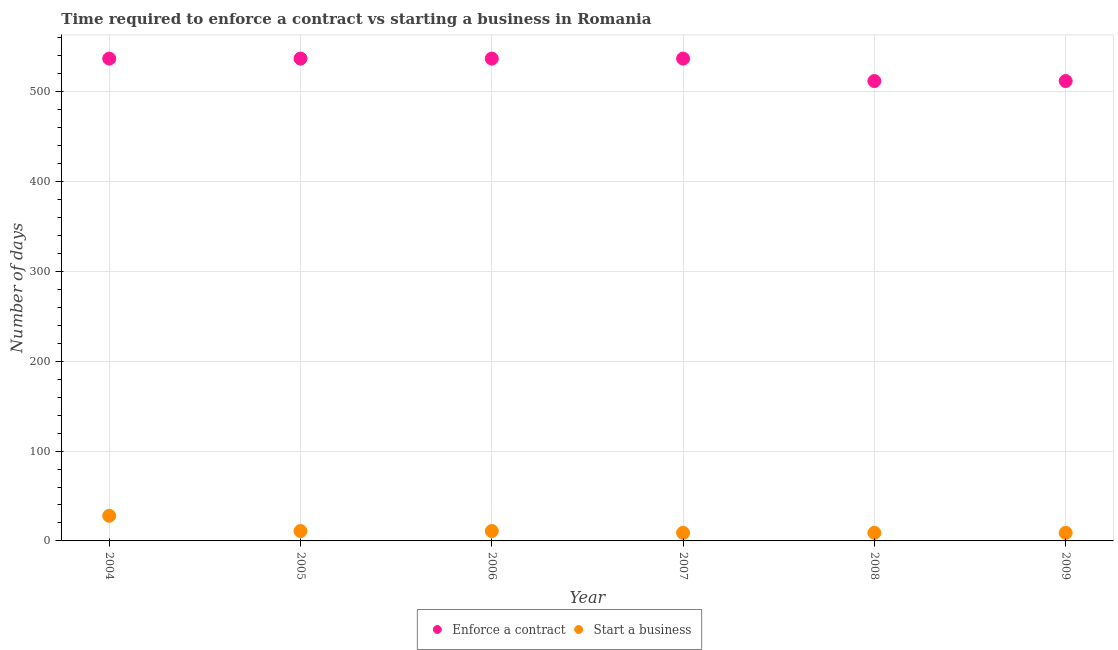What is the number of days to start a business in 2009?
Keep it short and to the point. 9. Across all years, what is the maximum number of days to start a business?
Offer a very short reply. 28. Across all years, what is the minimum number of days to start a business?
Make the answer very short. 9. What is the total number of days to enforece a contract in the graph?
Keep it short and to the point. 3172. What is the difference between the number of days to start a business in 2006 and that in 2007?
Offer a very short reply. 2. What is the difference between the number of days to start a business in 2007 and the number of days to enforece a contract in 2004?
Give a very brief answer. -528. What is the average number of days to enforece a contract per year?
Your response must be concise. 528.67. In the year 2004, what is the difference between the number of days to start a business and number of days to enforece a contract?
Keep it short and to the point. -509. In how many years, is the number of days to start a business greater than 240 days?
Offer a terse response. 0. Is the number of days to enforece a contract in 2007 less than that in 2009?
Ensure brevity in your answer.  No. What is the difference between the highest and the second highest number of days to start a business?
Your response must be concise. 17. What is the difference between the highest and the lowest number of days to enforece a contract?
Ensure brevity in your answer.  25. In how many years, is the number of days to start a business greater than the average number of days to start a business taken over all years?
Provide a succinct answer. 1. Is the sum of the number of days to start a business in 2004 and 2006 greater than the maximum number of days to enforece a contract across all years?
Your response must be concise. No. Does the number of days to start a business monotonically increase over the years?
Keep it short and to the point. No. Is the number of days to start a business strictly greater than the number of days to enforece a contract over the years?
Offer a terse response. No. How many dotlines are there?
Offer a terse response. 2. How many years are there in the graph?
Your answer should be compact. 6. What is the difference between two consecutive major ticks on the Y-axis?
Provide a short and direct response. 100. Are the values on the major ticks of Y-axis written in scientific E-notation?
Make the answer very short. No. Does the graph contain any zero values?
Your answer should be compact. No. Does the graph contain grids?
Your response must be concise. Yes. What is the title of the graph?
Offer a terse response. Time required to enforce a contract vs starting a business in Romania. Does "Non-resident workers" appear as one of the legend labels in the graph?
Offer a very short reply. No. What is the label or title of the X-axis?
Offer a very short reply. Year. What is the label or title of the Y-axis?
Offer a terse response. Number of days. What is the Number of days in Enforce a contract in 2004?
Offer a terse response. 537. What is the Number of days of Enforce a contract in 2005?
Offer a terse response. 537. What is the Number of days of Enforce a contract in 2006?
Provide a short and direct response. 537. What is the Number of days of Start a business in 2006?
Provide a short and direct response. 11. What is the Number of days of Enforce a contract in 2007?
Keep it short and to the point. 537. What is the Number of days of Start a business in 2007?
Make the answer very short. 9. What is the Number of days of Enforce a contract in 2008?
Your response must be concise. 512. What is the Number of days in Enforce a contract in 2009?
Offer a very short reply. 512. What is the Number of days in Start a business in 2009?
Provide a short and direct response. 9. Across all years, what is the maximum Number of days in Enforce a contract?
Provide a short and direct response. 537. Across all years, what is the minimum Number of days in Enforce a contract?
Ensure brevity in your answer.  512. What is the total Number of days of Enforce a contract in the graph?
Your answer should be very brief. 3172. What is the difference between the Number of days of Start a business in 2004 and that in 2005?
Provide a succinct answer. 17. What is the difference between the Number of days in Enforce a contract in 2004 and that in 2006?
Offer a very short reply. 0. What is the difference between the Number of days of Start a business in 2004 and that in 2006?
Keep it short and to the point. 17. What is the difference between the Number of days in Enforce a contract in 2004 and that in 2007?
Make the answer very short. 0. What is the difference between the Number of days in Enforce a contract in 2004 and that in 2008?
Offer a very short reply. 25. What is the difference between the Number of days of Start a business in 2005 and that in 2006?
Offer a terse response. 0. What is the difference between the Number of days of Enforce a contract in 2005 and that in 2007?
Keep it short and to the point. 0. What is the difference between the Number of days in Enforce a contract in 2005 and that in 2008?
Make the answer very short. 25. What is the difference between the Number of days of Enforce a contract in 2005 and that in 2009?
Your answer should be very brief. 25. What is the difference between the Number of days in Start a business in 2005 and that in 2009?
Offer a terse response. 2. What is the difference between the Number of days in Enforce a contract in 2006 and that in 2007?
Your response must be concise. 0. What is the difference between the Number of days in Start a business in 2006 and that in 2007?
Your answer should be compact. 2. What is the difference between the Number of days in Start a business in 2006 and that in 2008?
Keep it short and to the point. 2. What is the difference between the Number of days of Enforce a contract in 2006 and that in 2009?
Offer a terse response. 25. What is the difference between the Number of days of Start a business in 2006 and that in 2009?
Offer a terse response. 2. What is the difference between the Number of days of Start a business in 2007 and that in 2008?
Your answer should be very brief. 0. What is the difference between the Number of days in Enforce a contract in 2004 and the Number of days in Start a business in 2005?
Give a very brief answer. 526. What is the difference between the Number of days of Enforce a contract in 2004 and the Number of days of Start a business in 2006?
Provide a succinct answer. 526. What is the difference between the Number of days in Enforce a contract in 2004 and the Number of days in Start a business in 2007?
Provide a short and direct response. 528. What is the difference between the Number of days of Enforce a contract in 2004 and the Number of days of Start a business in 2008?
Give a very brief answer. 528. What is the difference between the Number of days of Enforce a contract in 2004 and the Number of days of Start a business in 2009?
Keep it short and to the point. 528. What is the difference between the Number of days in Enforce a contract in 2005 and the Number of days in Start a business in 2006?
Your answer should be very brief. 526. What is the difference between the Number of days in Enforce a contract in 2005 and the Number of days in Start a business in 2007?
Ensure brevity in your answer.  528. What is the difference between the Number of days in Enforce a contract in 2005 and the Number of days in Start a business in 2008?
Your answer should be compact. 528. What is the difference between the Number of days in Enforce a contract in 2005 and the Number of days in Start a business in 2009?
Keep it short and to the point. 528. What is the difference between the Number of days of Enforce a contract in 2006 and the Number of days of Start a business in 2007?
Make the answer very short. 528. What is the difference between the Number of days in Enforce a contract in 2006 and the Number of days in Start a business in 2008?
Your response must be concise. 528. What is the difference between the Number of days in Enforce a contract in 2006 and the Number of days in Start a business in 2009?
Your answer should be compact. 528. What is the difference between the Number of days of Enforce a contract in 2007 and the Number of days of Start a business in 2008?
Give a very brief answer. 528. What is the difference between the Number of days of Enforce a contract in 2007 and the Number of days of Start a business in 2009?
Make the answer very short. 528. What is the difference between the Number of days in Enforce a contract in 2008 and the Number of days in Start a business in 2009?
Offer a very short reply. 503. What is the average Number of days of Enforce a contract per year?
Your response must be concise. 528.67. What is the average Number of days in Start a business per year?
Offer a very short reply. 12.83. In the year 2004, what is the difference between the Number of days of Enforce a contract and Number of days of Start a business?
Provide a succinct answer. 509. In the year 2005, what is the difference between the Number of days of Enforce a contract and Number of days of Start a business?
Make the answer very short. 526. In the year 2006, what is the difference between the Number of days in Enforce a contract and Number of days in Start a business?
Offer a terse response. 526. In the year 2007, what is the difference between the Number of days of Enforce a contract and Number of days of Start a business?
Make the answer very short. 528. In the year 2008, what is the difference between the Number of days in Enforce a contract and Number of days in Start a business?
Provide a succinct answer. 503. In the year 2009, what is the difference between the Number of days of Enforce a contract and Number of days of Start a business?
Keep it short and to the point. 503. What is the ratio of the Number of days of Enforce a contract in 2004 to that in 2005?
Make the answer very short. 1. What is the ratio of the Number of days of Start a business in 2004 to that in 2005?
Your answer should be compact. 2.55. What is the ratio of the Number of days of Start a business in 2004 to that in 2006?
Your answer should be very brief. 2.55. What is the ratio of the Number of days in Start a business in 2004 to that in 2007?
Ensure brevity in your answer.  3.11. What is the ratio of the Number of days of Enforce a contract in 2004 to that in 2008?
Give a very brief answer. 1.05. What is the ratio of the Number of days in Start a business in 2004 to that in 2008?
Your answer should be very brief. 3.11. What is the ratio of the Number of days in Enforce a contract in 2004 to that in 2009?
Give a very brief answer. 1.05. What is the ratio of the Number of days of Start a business in 2004 to that in 2009?
Offer a very short reply. 3.11. What is the ratio of the Number of days in Enforce a contract in 2005 to that in 2007?
Your answer should be compact. 1. What is the ratio of the Number of days in Start a business in 2005 to that in 2007?
Offer a very short reply. 1.22. What is the ratio of the Number of days of Enforce a contract in 2005 to that in 2008?
Give a very brief answer. 1.05. What is the ratio of the Number of days in Start a business in 2005 to that in 2008?
Your response must be concise. 1.22. What is the ratio of the Number of days in Enforce a contract in 2005 to that in 2009?
Provide a succinct answer. 1.05. What is the ratio of the Number of days in Start a business in 2005 to that in 2009?
Your answer should be very brief. 1.22. What is the ratio of the Number of days of Start a business in 2006 to that in 2007?
Provide a succinct answer. 1.22. What is the ratio of the Number of days in Enforce a contract in 2006 to that in 2008?
Offer a terse response. 1.05. What is the ratio of the Number of days in Start a business in 2006 to that in 2008?
Your answer should be compact. 1.22. What is the ratio of the Number of days of Enforce a contract in 2006 to that in 2009?
Provide a succinct answer. 1.05. What is the ratio of the Number of days in Start a business in 2006 to that in 2009?
Provide a short and direct response. 1.22. What is the ratio of the Number of days of Enforce a contract in 2007 to that in 2008?
Offer a very short reply. 1.05. What is the ratio of the Number of days in Start a business in 2007 to that in 2008?
Your answer should be very brief. 1. What is the ratio of the Number of days in Enforce a contract in 2007 to that in 2009?
Provide a succinct answer. 1.05. What is the ratio of the Number of days in Enforce a contract in 2008 to that in 2009?
Your answer should be compact. 1. What is the ratio of the Number of days of Start a business in 2008 to that in 2009?
Ensure brevity in your answer.  1. What is the difference between the highest and the second highest Number of days of Enforce a contract?
Provide a short and direct response. 0. 